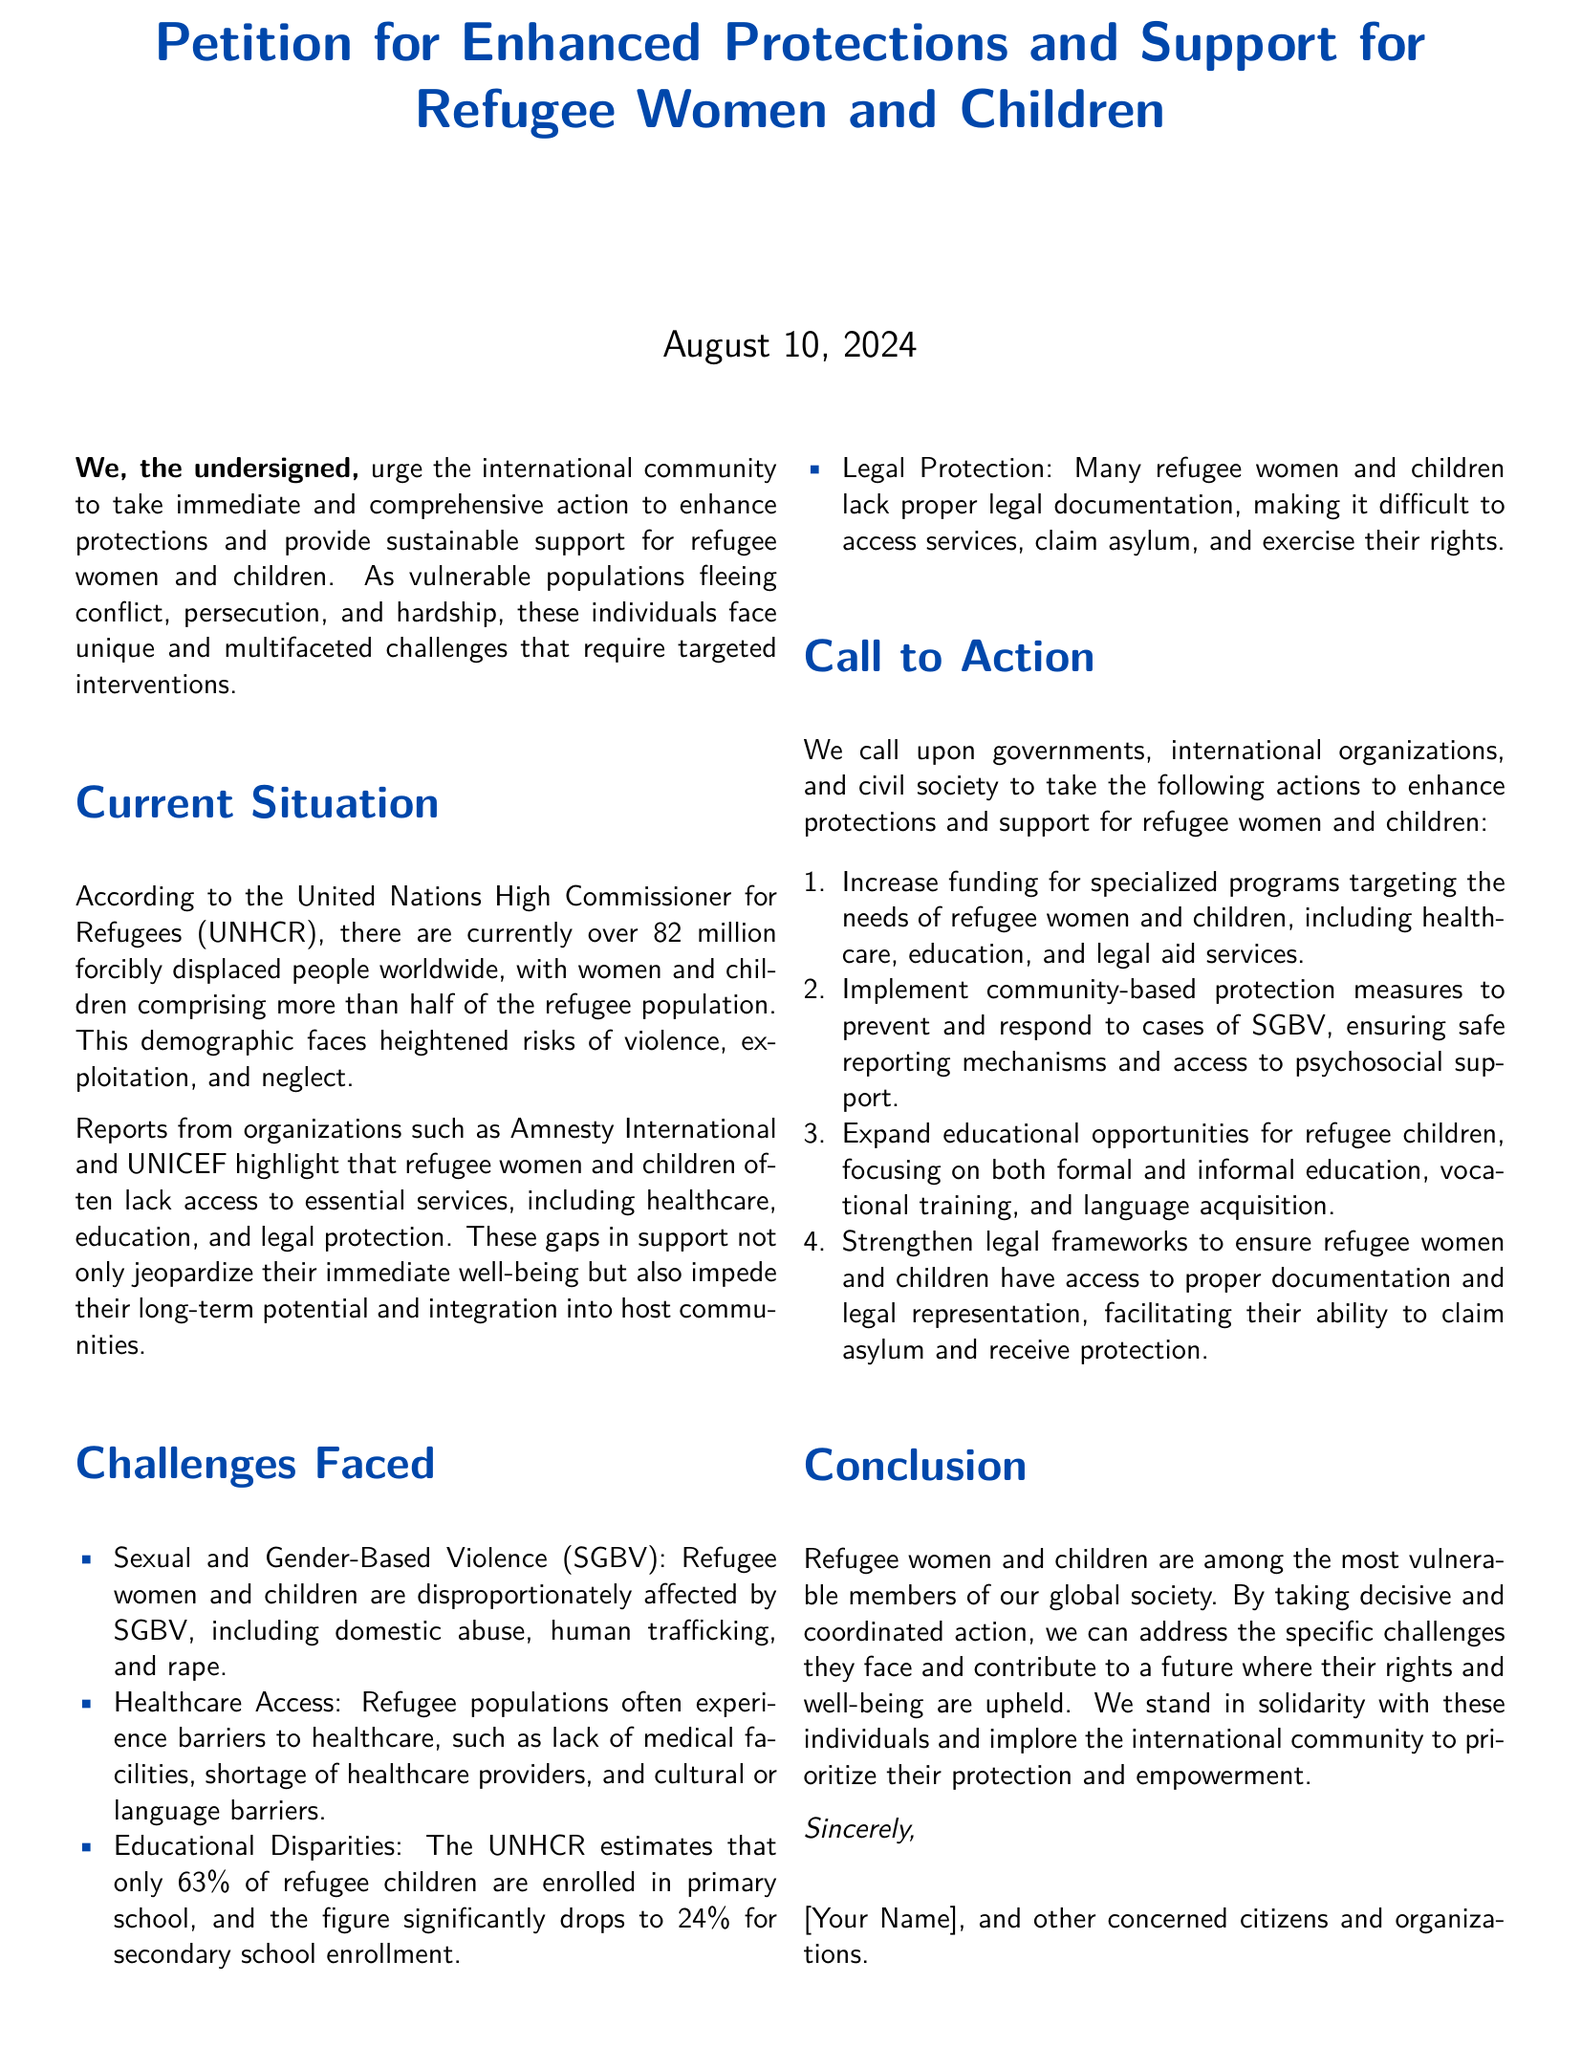what is the total number of forcibly displaced people worldwide? The total number of forcibly displaced people according to the UNHCR is stated in the document as over 82 million.
Answer: over 82 million what percentage of refugee children are enrolled in primary school? The document states that the UNHCR estimates that only 63% of refugee children are enrolled in primary school.
Answer: 63% what are the four specific actions called for in the petition? The document lists four actions under the "Call to Action" section, which includes increasing funding, implementing protection measures, expanding educational opportunities, and strengthening legal frameworks.
Answer: Increase funding, implement community-based protection measures, expand educational opportunities, strengthen legal frameworks which organization emphasizes the unique challenges faced by refugee women and children? The document mentions that reports from organizations such as Amnesty International and UNICEF highlight these challenges.
Answer: Amnesty International and UNICEF what is a significant barrier to healthcare access for refugees? The document identifies barriers such as lack of medical facilities, shortage of healthcare providers, and cultural or language barriers.
Answer: Lack of medical facilities what demographic primarily comprises the refugee population? The document indicates that women and children comprise more than half of the refugee population.
Answer: women and children what type of violence are refugee women and children disproportionately affected by? The document specifically mentions sexual and gender-based violence (SGBV).
Answer: Sexual and Gender-Based Violence (SGBV) what is the focus of the educational disparities mentioned in the petition? The petition emphasizes that educational disparities affect enrollment in primary and secondary school for refugee children.
Answer: Enrollment in primary and secondary school 